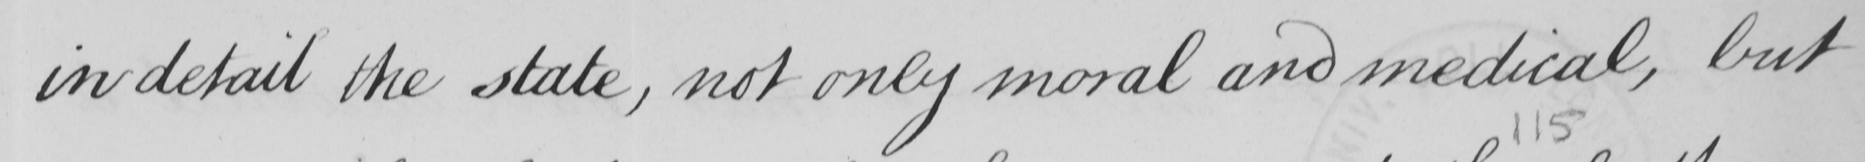Please transcribe the handwritten text in this image. in detail the state , not only moral and medical , but 